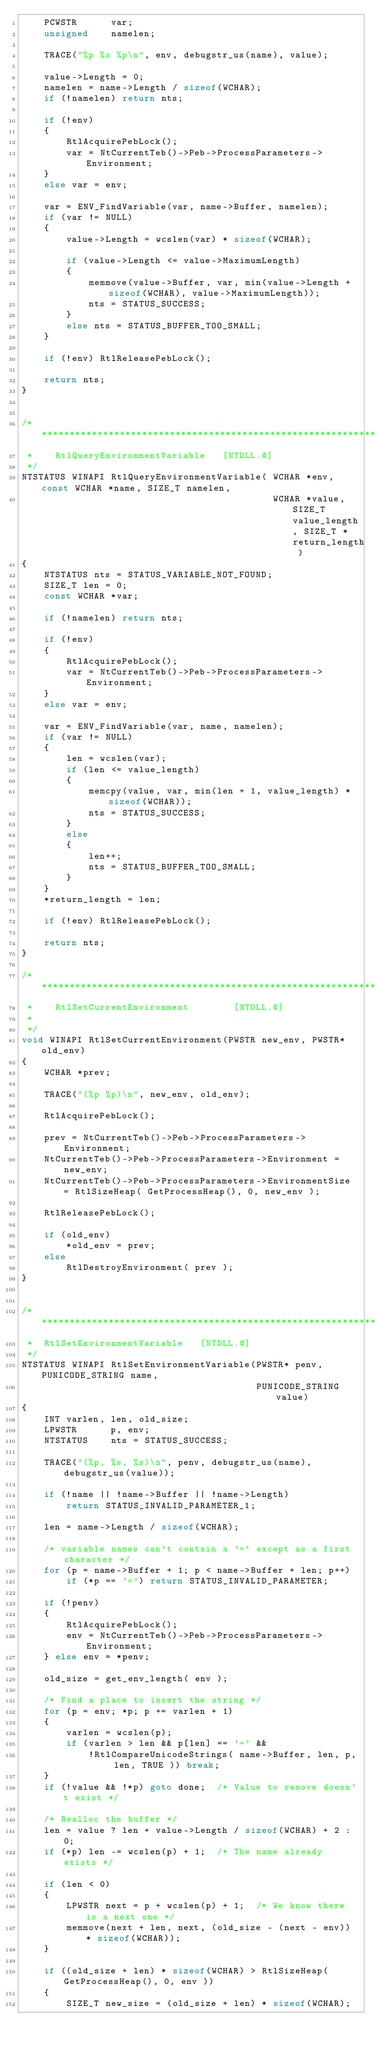<code> <loc_0><loc_0><loc_500><loc_500><_C_>    PCWSTR      var;
    unsigned    namelen;

    TRACE("%p %s %p\n", env, debugstr_us(name), value);

    value->Length = 0;
    namelen = name->Length / sizeof(WCHAR);
    if (!namelen) return nts;

    if (!env)
    {
        RtlAcquirePebLock();
        var = NtCurrentTeb()->Peb->ProcessParameters->Environment;
    }
    else var = env;

    var = ENV_FindVariable(var, name->Buffer, namelen);
    if (var != NULL)
    {
        value->Length = wcslen(var) * sizeof(WCHAR);

        if (value->Length <= value->MaximumLength)
        {
            memmove(value->Buffer, var, min(value->Length + sizeof(WCHAR), value->MaximumLength));
            nts = STATUS_SUCCESS;
        }
        else nts = STATUS_BUFFER_TOO_SMALL;
    }

    if (!env) RtlReleasePebLock();

    return nts;
}


/******************************************************************
 *		RtlQueryEnvironmentVariable   [NTDLL.@]
 */
NTSTATUS WINAPI RtlQueryEnvironmentVariable( WCHAR *env, const WCHAR *name, SIZE_T namelen,
                                             WCHAR *value, SIZE_T value_length, SIZE_T *return_length )
{
    NTSTATUS nts = STATUS_VARIABLE_NOT_FOUND;
    SIZE_T len = 0;
    const WCHAR *var;

    if (!namelen) return nts;

    if (!env)
    {
        RtlAcquirePebLock();
        var = NtCurrentTeb()->Peb->ProcessParameters->Environment;
    }
    else var = env;

    var = ENV_FindVariable(var, name, namelen);
    if (var != NULL)
    {
        len = wcslen(var);
        if (len <= value_length)
        {
            memcpy(value, var, min(len + 1, value_length) * sizeof(WCHAR));
            nts = STATUS_SUCCESS;
        }
        else
        {
            len++;
            nts = STATUS_BUFFER_TOO_SMALL;
        }
    }
    *return_length = len;

    if (!env) RtlReleasePebLock();

    return nts;
}

/******************************************************************
 *		RtlSetCurrentEnvironment        [NTDLL.@]
 *
 */
void WINAPI RtlSetCurrentEnvironment(PWSTR new_env, PWSTR* old_env)
{
    WCHAR *prev;

    TRACE("(%p %p)\n", new_env, old_env);

    RtlAcquirePebLock();

    prev = NtCurrentTeb()->Peb->ProcessParameters->Environment;
    NtCurrentTeb()->Peb->ProcessParameters->Environment = new_env;
    NtCurrentTeb()->Peb->ProcessParameters->EnvironmentSize = RtlSizeHeap( GetProcessHeap(), 0, new_env );

    RtlReleasePebLock();

    if (old_env)
        *old_env = prev;
    else
        RtlDestroyEnvironment( prev );
}


/******************************************************************************
 *  RtlSetEnvironmentVariable		[NTDLL.@]
 */
NTSTATUS WINAPI RtlSetEnvironmentVariable(PWSTR* penv, PUNICODE_STRING name, 
                                          PUNICODE_STRING value)
{
    INT varlen, len, old_size;
    LPWSTR      p, env;
    NTSTATUS    nts = STATUS_SUCCESS;

    TRACE("(%p, %s, %s)\n", penv, debugstr_us(name), debugstr_us(value));

    if (!name || !name->Buffer || !name->Length)
        return STATUS_INVALID_PARAMETER_1;

    len = name->Length / sizeof(WCHAR);

    /* variable names can't contain a '=' except as a first character */
    for (p = name->Buffer + 1; p < name->Buffer + len; p++)
        if (*p == '=') return STATUS_INVALID_PARAMETER;

    if (!penv)
    {
        RtlAcquirePebLock();
        env = NtCurrentTeb()->Peb->ProcessParameters->Environment;
    } else env = *penv;

    old_size = get_env_length( env );

    /* Find a place to insert the string */
    for (p = env; *p; p += varlen + 1)
    {
        varlen = wcslen(p);
        if (varlen > len && p[len] == '=' &&
            !RtlCompareUnicodeStrings( name->Buffer, len, p, len, TRUE )) break;
    }
    if (!value && !*p) goto done;  /* Value to remove doesn't exist */

    /* Realloc the buffer */
    len = value ? len + value->Length / sizeof(WCHAR) + 2 : 0;
    if (*p) len -= wcslen(p) + 1;  /* The name already exists */

    if (len < 0)
    {
        LPWSTR next = p + wcslen(p) + 1;  /* We know there is a next one */
        memmove(next + len, next, (old_size - (next - env)) * sizeof(WCHAR));
    }

    if ((old_size + len) * sizeof(WCHAR) > RtlSizeHeap( GetProcessHeap(), 0, env ))
    {
        SIZE_T new_size = (old_size + len) * sizeof(WCHAR);</code> 